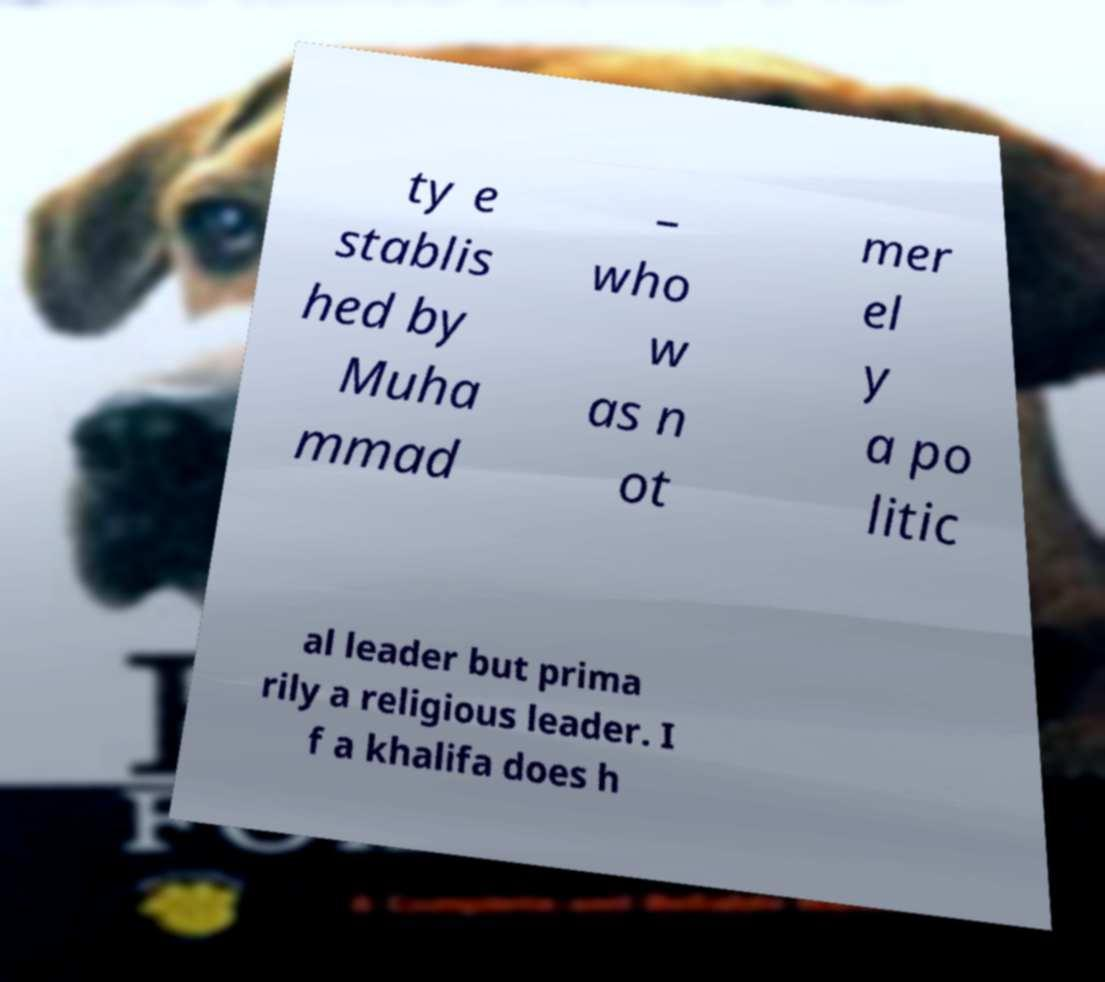Please read and relay the text visible in this image. What does it say? ty e stablis hed by Muha mmad – who w as n ot mer el y a po litic al leader but prima rily a religious leader. I f a khalifa does h 